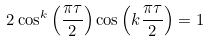Convert formula to latex. <formula><loc_0><loc_0><loc_500><loc_500>2 \cos ^ { k } \left ( \frac { \pi \tau } { 2 } \right ) \cos \left ( k \frac { \pi \tau } { 2 } \right ) = 1</formula> 